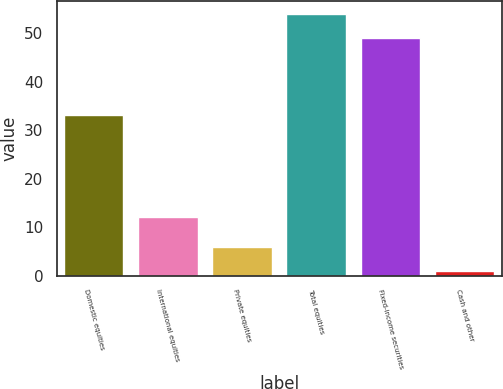Convert chart to OTSL. <chart><loc_0><loc_0><loc_500><loc_500><bar_chart><fcel>Domestic equities<fcel>International equities<fcel>Private equities<fcel>Total equities<fcel>Fixed-income securities<fcel>Cash and other<nl><fcel>33<fcel>12<fcel>5.9<fcel>53.9<fcel>49<fcel>1<nl></chart> 